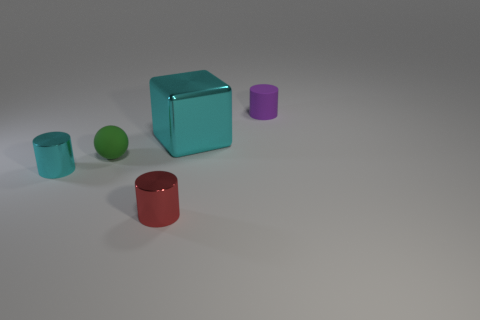How many things are either things left of the tiny purple object or small shiny cylinders left of the green sphere?
Your answer should be very brief. 4. Is the number of small metallic objects on the left side of the small cyan object less than the number of small yellow metallic spheres?
Your response must be concise. No. Is the purple cylinder made of the same material as the small green ball that is to the left of the red metallic thing?
Keep it short and to the point. Yes. What material is the red thing?
Make the answer very short. Metal. The cylinder that is behind the metallic object that is left of the small rubber thing on the left side of the red cylinder is made of what material?
Offer a terse response. Rubber. There is a metal block; is its color the same as the metallic cylinder that is to the left of the tiny green rubber object?
Keep it short and to the point. Yes. Is there anything else that has the same shape as the tiny green rubber object?
Provide a succinct answer. No. What color is the metallic object that is in front of the metallic cylinder that is to the left of the red shiny cylinder?
Ensure brevity in your answer.  Red. How many tiny matte things are there?
Your answer should be compact. 2. What number of rubber objects are either small purple objects or yellow spheres?
Make the answer very short. 1. 